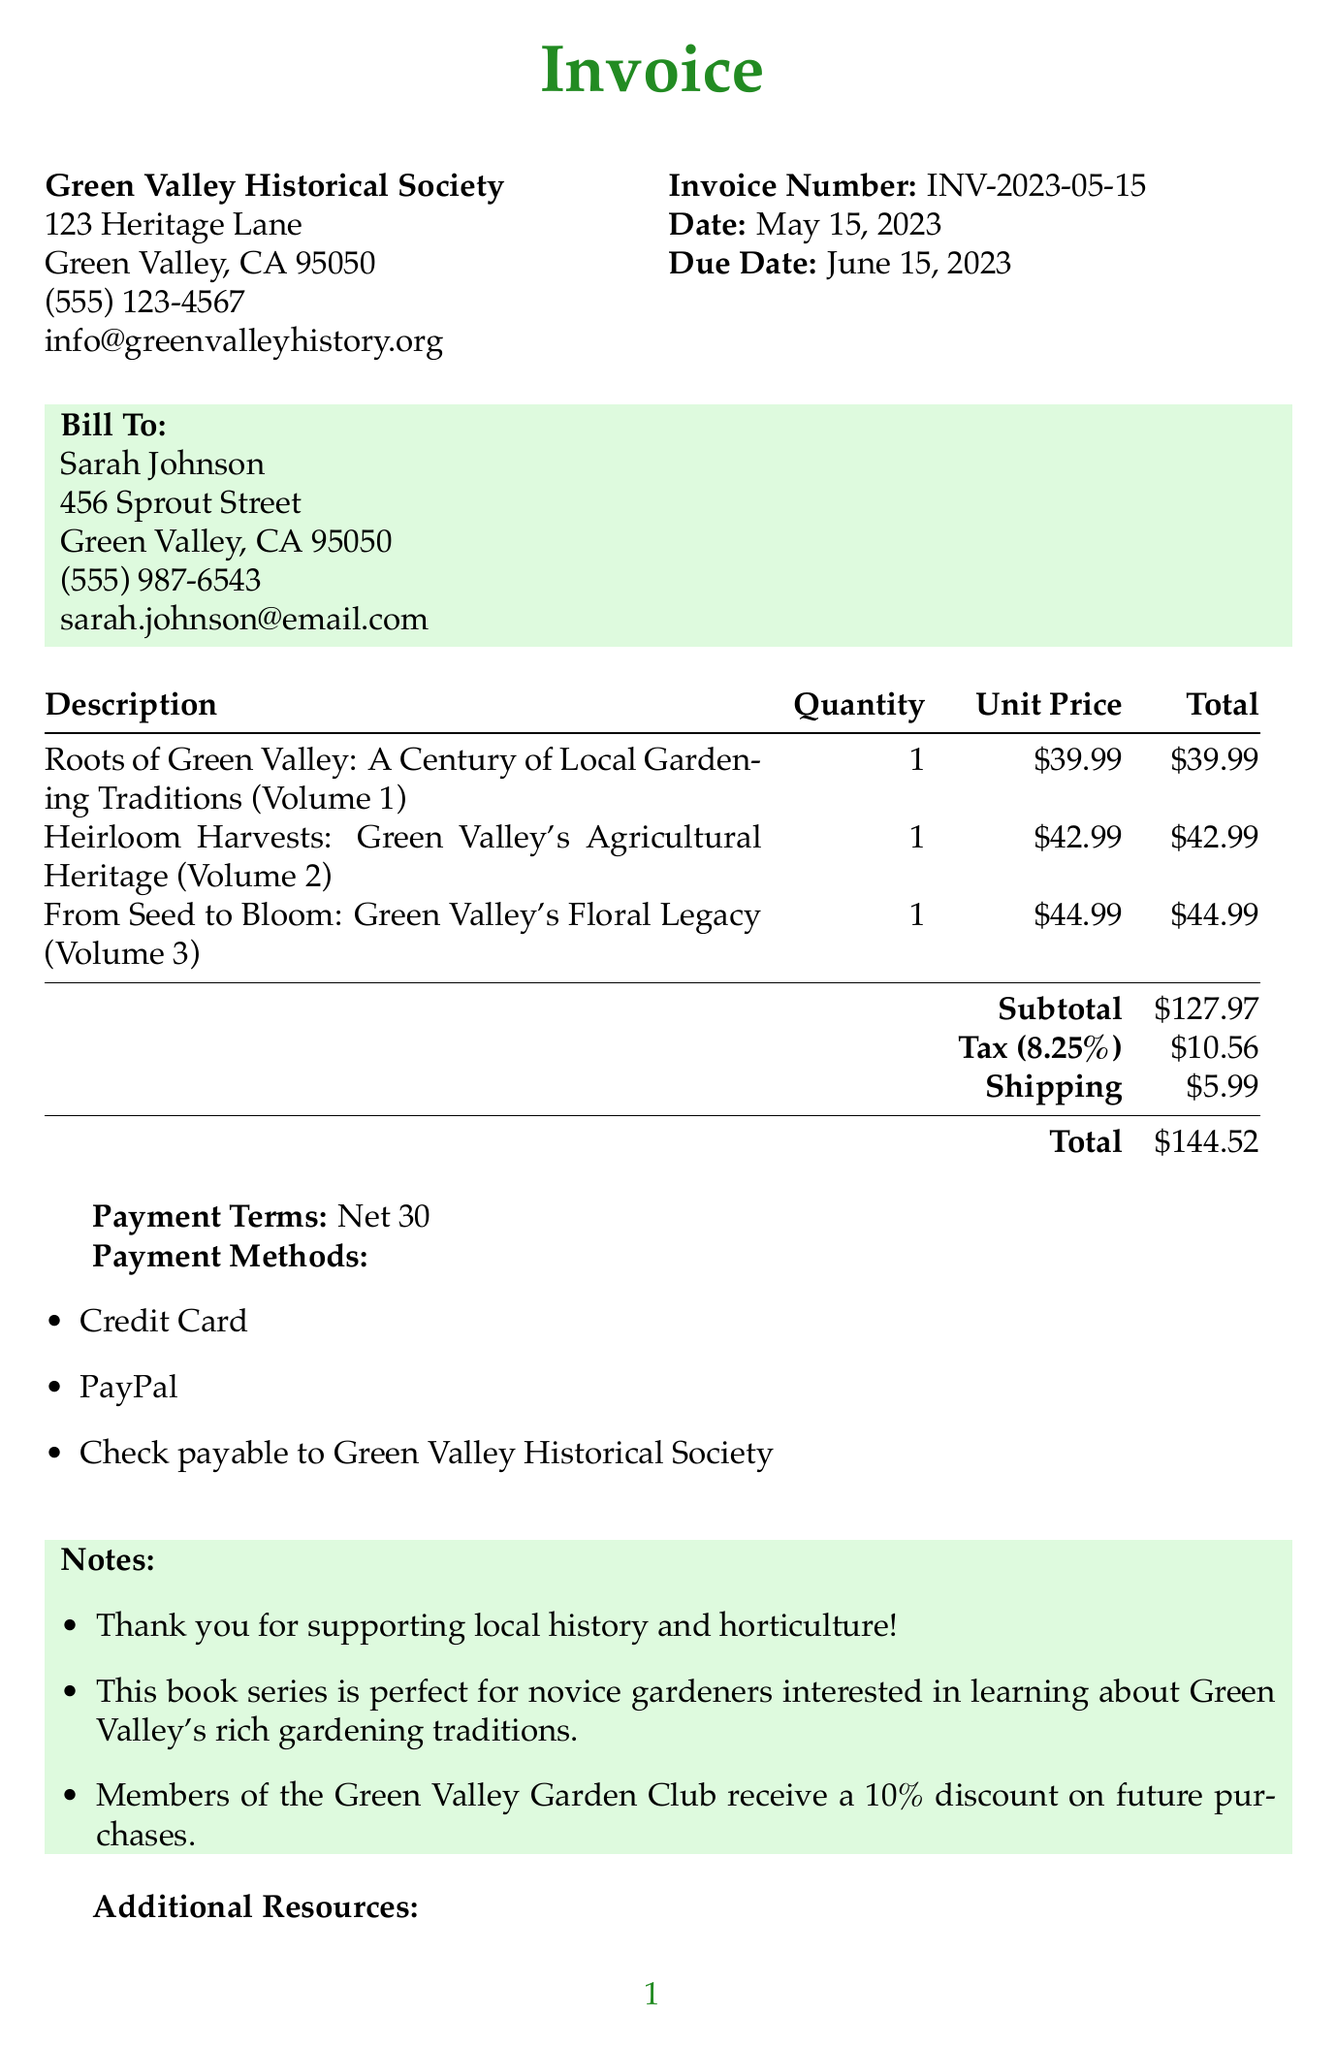What is the invoice number? The invoice number is specified at the top of the document under "Invoice Number."
Answer: INV-2023-05-15 Who is the seller? The seller's name can be found in the seller's section of the invoice.
Answer: Green Valley Historical Society What is the due date? The due date is mentioned alongside the invoice date, indicating when payment is needed.
Answer: June 15, 2023 How many items are listed in the invoice? The number of items can be counted in the itemized list shown in the invoice.
Answer: 3 What is the subtotal amount before tax? The subtotal is an amount provided in the summary section of the invoice before tax and shipping are added.
Answer: 127.97 What type of discount do members of the Green Valley Garden Club receive? The type of discount is indicated in the notes section of the invoice.
Answer: 10 percent What is the total amount due? The total amount due can be found in the summary section of the invoice.
Answer: 144.52 What are the payment methods accepted? The accepted payment methods can be found in the payment methods section of the invoice.
Answer: Credit Card, PayPal, Check payable to Green Valley Historical Society What additional resource comes with the purchase? The additional resources are listed in a section that includes benefits for buyers.
Answer: Free guided tour of the Green Valley Heritage Garden with purchase 